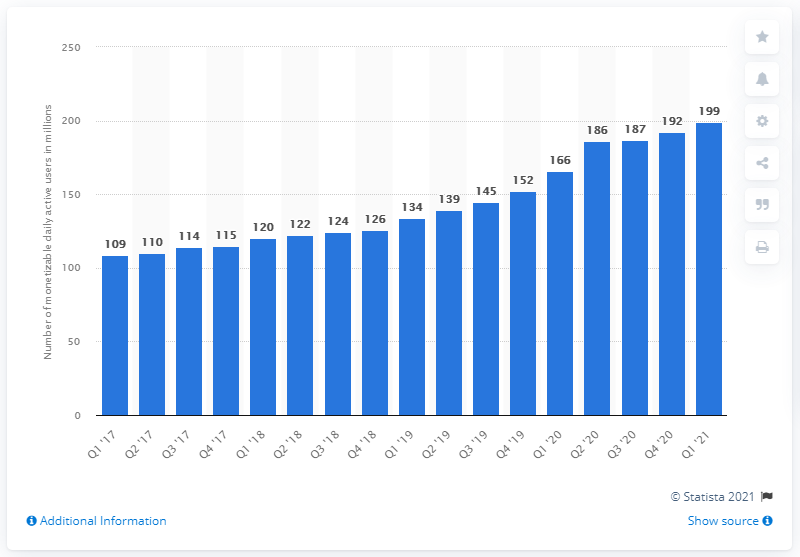List a handful of essential elements in this visual. There were 199 million global mDAU (monthly active users) in the last quarter of 2021. 